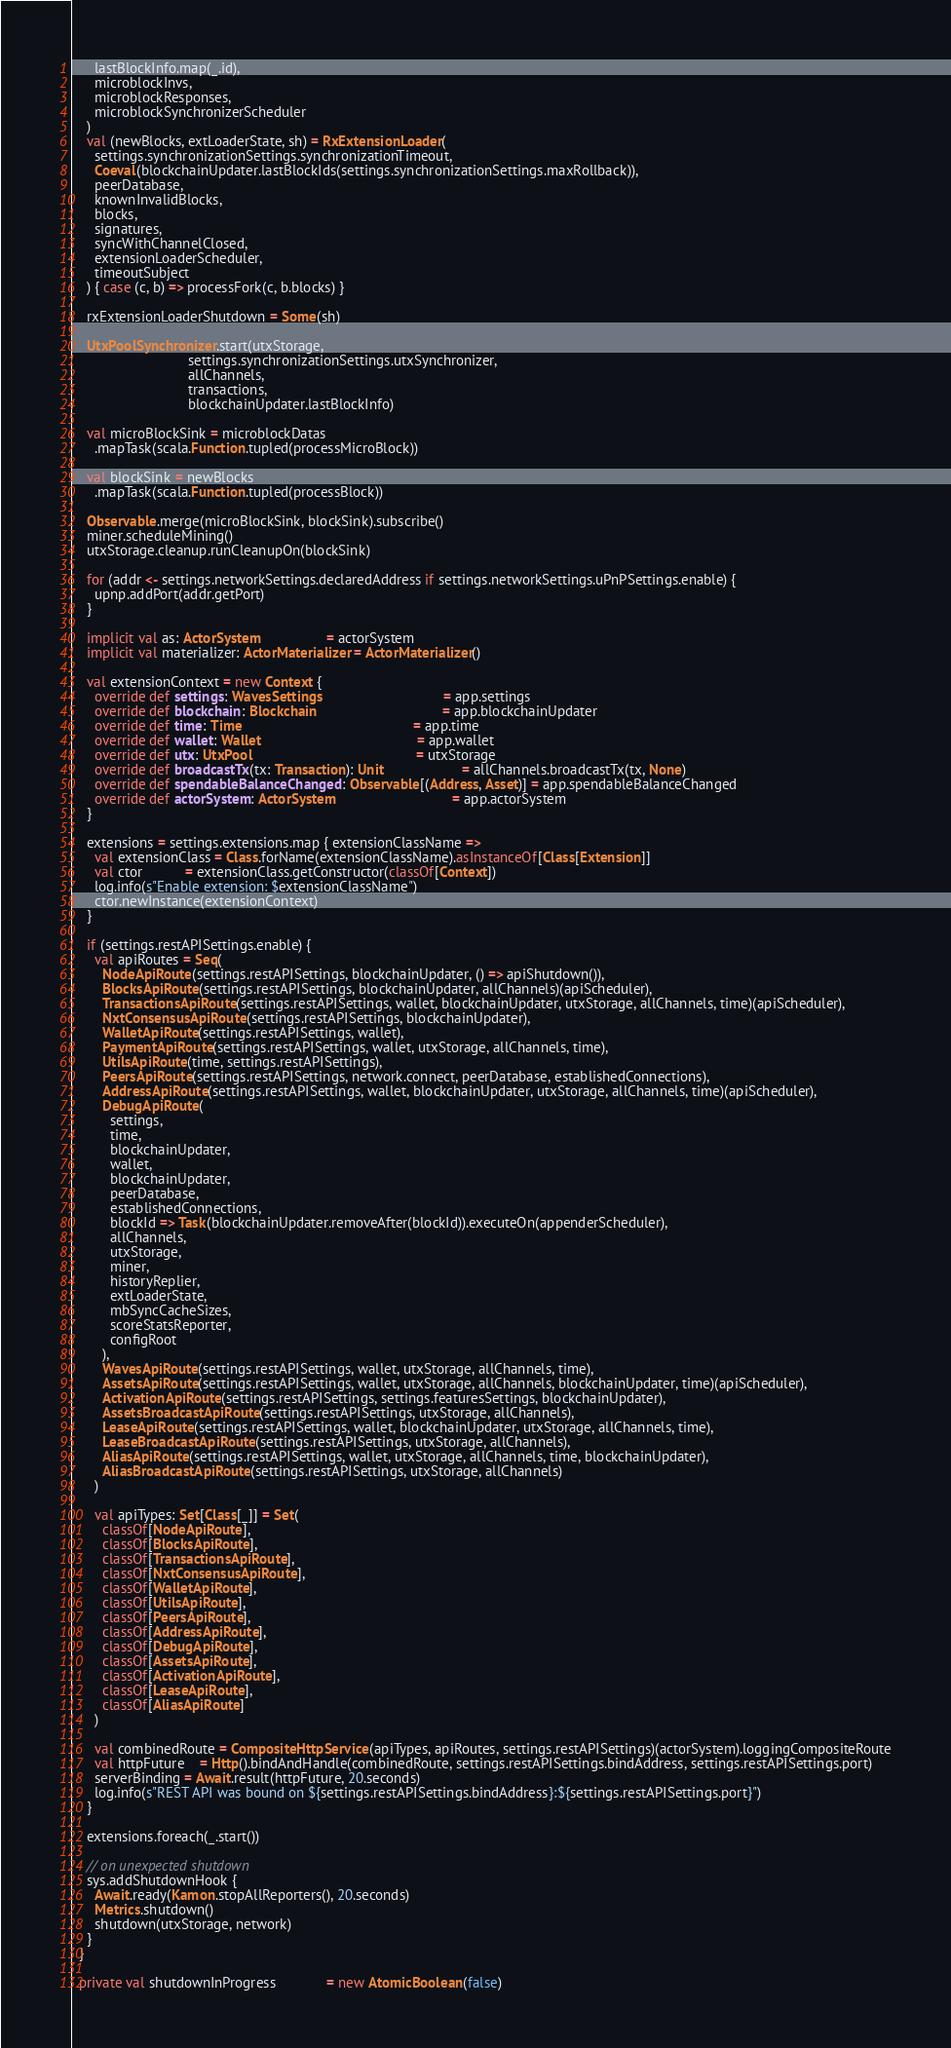<code> <loc_0><loc_0><loc_500><loc_500><_Scala_>      lastBlockInfo.map(_.id),
      microblockInvs,
      microblockResponses,
      microblockSynchronizerScheduler
    )
    val (newBlocks, extLoaderState, sh) = RxExtensionLoader(
      settings.synchronizationSettings.synchronizationTimeout,
      Coeval(blockchainUpdater.lastBlockIds(settings.synchronizationSettings.maxRollback)),
      peerDatabase,
      knownInvalidBlocks,
      blocks,
      signatures,
      syncWithChannelClosed,
      extensionLoaderScheduler,
      timeoutSubject
    ) { case (c, b) => processFork(c, b.blocks) }

    rxExtensionLoaderShutdown = Some(sh)

    UtxPoolSynchronizer.start(utxStorage,
                              settings.synchronizationSettings.utxSynchronizer,
                              allChannels,
                              transactions,
                              blockchainUpdater.lastBlockInfo)

    val microBlockSink = microblockDatas
      .mapTask(scala.Function.tupled(processMicroBlock))

    val blockSink = newBlocks
      .mapTask(scala.Function.tupled(processBlock))

    Observable.merge(microBlockSink, blockSink).subscribe()
    miner.scheduleMining()
    utxStorage.cleanup.runCleanupOn(blockSink)

    for (addr <- settings.networkSettings.declaredAddress if settings.networkSettings.uPnPSettings.enable) {
      upnp.addPort(addr.getPort)
    }

    implicit val as: ActorSystem                 = actorSystem
    implicit val materializer: ActorMaterializer = ActorMaterializer()

    val extensionContext = new Context {
      override def settings: WavesSettings                               = app.settings
      override def blockchain: Blockchain                                = app.blockchainUpdater
      override def time: Time                                            = app.time
      override def wallet: Wallet                                        = app.wallet
      override def utx: UtxPool                                          = utxStorage
      override def broadcastTx(tx: Transaction): Unit                    = allChannels.broadcastTx(tx, None)
      override def spendableBalanceChanged: Observable[(Address, Asset)] = app.spendableBalanceChanged
      override def actorSystem: ActorSystem                              = app.actorSystem
    }

    extensions = settings.extensions.map { extensionClassName =>
      val extensionClass = Class.forName(extensionClassName).asInstanceOf[Class[Extension]]
      val ctor           = extensionClass.getConstructor(classOf[Context])
      log.info(s"Enable extension: $extensionClassName")
      ctor.newInstance(extensionContext)
    }

    if (settings.restAPISettings.enable) {
      val apiRoutes = Seq(
        NodeApiRoute(settings.restAPISettings, blockchainUpdater, () => apiShutdown()),
        BlocksApiRoute(settings.restAPISettings, blockchainUpdater, allChannels)(apiScheduler),
        TransactionsApiRoute(settings.restAPISettings, wallet, blockchainUpdater, utxStorage, allChannels, time)(apiScheduler),
        NxtConsensusApiRoute(settings.restAPISettings, blockchainUpdater),
        WalletApiRoute(settings.restAPISettings, wallet),
        PaymentApiRoute(settings.restAPISettings, wallet, utxStorage, allChannels, time),
        UtilsApiRoute(time, settings.restAPISettings),
        PeersApiRoute(settings.restAPISettings, network.connect, peerDatabase, establishedConnections),
        AddressApiRoute(settings.restAPISettings, wallet, blockchainUpdater, utxStorage, allChannels, time)(apiScheduler),
        DebugApiRoute(
          settings,
          time,
          blockchainUpdater,
          wallet,
          blockchainUpdater,
          peerDatabase,
          establishedConnections,
          blockId => Task(blockchainUpdater.removeAfter(blockId)).executeOn(appenderScheduler),
          allChannels,
          utxStorage,
          miner,
          historyReplier,
          extLoaderState,
          mbSyncCacheSizes,
          scoreStatsReporter,
          configRoot
        ),
        WavesApiRoute(settings.restAPISettings, wallet, utxStorage, allChannels, time),
        AssetsApiRoute(settings.restAPISettings, wallet, utxStorage, allChannels, blockchainUpdater, time)(apiScheduler),
        ActivationApiRoute(settings.restAPISettings, settings.featuresSettings, blockchainUpdater),
        AssetsBroadcastApiRoute(settings.restAPISettings, utxStorage, allChannels),
        LeaseApiRoute(settings.restAPISettings, wallet, blockchainUpdater, utxStorage, allChannels, time),
        LeaseBroadcastApiRoute(settings.restAPISettings, utxStorage, allChannels),
        AliasApiRoute(settings.restAPISettings, wallet, utxStorage, allChannels, time, blockchainUpdater),
        AliasBroadcastApiRoute(settings.restAPISettings, utxStorage, allChannels)
      )

      val apiTypes: Set[Class[_]] = Set(
        classOf[NodeApiRoute],
        classOf[BlocksApiRoute],
        classOf[TransactionsApiRoute],
        classOf[NxtConsensusApiRoute],
        classOf[WalletApiRoute],
        classOf[UtilsApiRoute],
        classOf[PeersApiRoute],
        classOf[AddressApiRoute],
        classOf[DebugApiRoute],
        classOf[AssetsApiRoute],
        classOf[ActivationApiRoute],
        classOf[LeaseApiRoute],
        classOf[AliasApiRoute]
      )

      val combinedRoute = CompositeHttpService(apiTypes, apiRoutes, settings.restAPISettings)(actorSystem).loggingCompositeRoute
      val httpFuture    = Http().bindAndHandle(combinedRoute, settings.restAPISettings.bindAddress, settings.restAPISettings.port)
      serverBinding = Await.result(httpFuture, 20.seconds)
      log.info(s"REST API was bound on ${settings.restAPISettings.bindAddress}:${settings.restAPISettings.port}")
    }

    extensions.foreach(_.start())

    // on unexpected shutdown
    sys.addShutdownHook {
      Await.ready(Kamon.stopAllReporters(), 20.seconds)
      Metrics.shutdown()
      shutdown(utxStorage, network)
    }
  }

  private val shutdownInProgress             = new AtomicBoolean(false)</code> 